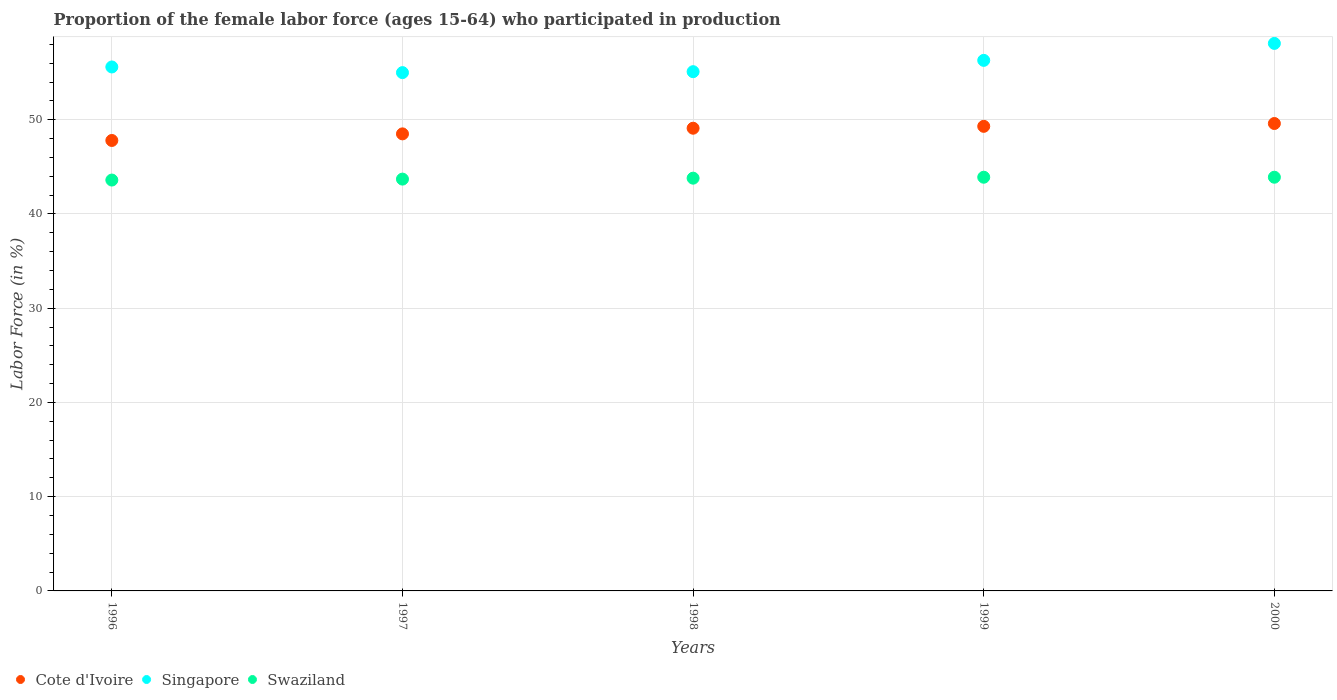What is the proportion of the female labor force who participated in production in Singapore in 2000?
Provide a succinct answer. 58.1. Across all years, what is the maximum proportion of the female labor force who participated in production in Swaziland?
Keep it short and to the point. 43.9. Across all years, what is the minimum proportion of the female labor force who participated in production in Swaziland?
Provide a short and direct response. 43.6. What is the total proportion of the female labor force who participated in production in Cote d'Ivoire in the graph?
Your answer should be very brief. 244.3. What is the difference between the proportion of the female labor force who participated in production in Cote d'Ivoire in 1996 and that in 1998?
Your answer should be compact. -1.3. What is the difference between the proportion of the female labor force who participated in production in Singapore in 1998 and the proportion of the female labor force who participated in production in Swaziland in 1999?
Make the answer very short. 11.2. What is the average proportion of the female labor force who participated in production in Cote d'Ivoire per year?
Give a very brief answer. 48.86. In the year 2000, what is the difference between the proportion of the female labor force who participated in production in Cote d'Ivoire and proportion of the female labor force who participated in production in Swaziland?
Provide a succinct answer. 5.7. What is the ratio of the proportion of the female labor force who participated in production in Swaziland in 1998 to that in 2000?
Give a very brief answer. 1. What is the difference between the highest and the second highest proportion of the female labor force who participated in production in Singapore?
Give a very brief answer. 1.8. What is the difference between the highest and the lowest proportion of the female labor force who participated in production in Swaziland?
Ensure brevity in your answer.  0.3. Does the proportion of the female labor force who participated in production in Singapore monotonically increase over the years?
Your response must be concise. No. Is the proportion of the female labor force who participated in production in Singapore strictly less than the proportion of the female labor force who participated in production in Cote d'Ivoire over the years?
Give a very brief answer. No. How many dotlines are there?
Offer a very short reply. 3. How many years are there in the graph?
Your answer should be compact. 5. What is the difference between two consecutive major ticks on the Y-axis?
Provide a short and direct response. 10. Where does the legend appear in the graph?
Your answer should be very brief. Bottom left. What is the title of the graph?
Keep it short and to the point. Proportion of the female labor force (ages 15-64) who participated in production. What is the label or title of the Y-axis?
Offer a terse response. Labor Force (in %). What is the Labor Force (in %) of Cote d'Ivoire in 1996?
Offer a terse response. 47.8. What is the Labor Force (in %) of Singapore in 1996?
Offer a terse response. 55.6. What is the Labor Force (in %) of Swaziland in 1996?
Make the answer very short. 43.6. What is the Labor Force (in %) in Cote d'Ivoire in 1997?
Your answer should be very brief. 48.5. What is the Labor Force (in %) of Swaziland in 1997?
Give a very brief answer. 43.7. What is the Labor Force (in %) of Cote d'Ivoire in 1998?
Your answer should be compact. 49.1. What is the Labor Force (in %) in Singapore in 1998?
Offer a very short reply. 55.1. What is the Labor Force (in %) in Swaziland in 1998?
Provide a short and direct response. 43.8. What is the Labor Force (in %) in Cote d'Ivoire in 1999?
Make the answer very short. 49.3. What is the Labor Force (in %) in Singapore in 1999?
Offer a very short reply. 56.3. What is the Labor Force (in %) of Swaziland in 1999?
Provide a succinct answer. 43.9. What is the Labor Force (in %) in Cote d'Ivoire in 2000?
Keep it short and to the point. 49.6. What is the Labor Force (in %) of Singapore in 2000?
Offer a very short reply. 58.1. What is the Labor Force (in %) in Swaziland in 2000?
Give a very brief answer. 43.9. Across all years, what is the maximum Labor Force (in %) in Cote d'Ivoire?
Offer a very short reply. 49.6. Across all years, what is the maximum Labor Force (in %) of Singapore?
Your answer should be very brief. 58.1. Across all years, what is the maximum Labor Force (in %) of Swaziland?
Provide a succinct answer. 43.9. Across all years, what is the minimum Labor Force (in %) of Cote d'Ivoire?
Ensure brevity in your answer.  47.8. Across all years, what is the minimum Labor Force (in %) of Singapore?
Provide a short and direct response. 55. Across all years, what is the minimum Labor Force (in %) in Swaziland?
Give a very brief answer. 43.6. What is the total Labor Force (in %) of Cote d'Ivoire in the graph?
Provide a succinct answer. 244.3. What is the total Labor Force (in %) in Singapore in the graph?
Give a very brief answer. 280.1. What is the total Labor Force (in %) in Swaziland in the graph?
Offer a terse response. 218.9. What is the difference between the Labor Force (in %) of Singapore in 1996 and that in 1998?
Offer a terse response. 0.5. What is the difference between the Labor Force (in %) in Cote d'Ivoire in 1996 and that in 1999?
Keep it short and to the point. -1.5. What is the difference between the Labor Force (in %) in Swaziland in 1996 and that in 1999?
Provide a short and direct response. -0.3. What is the difference between the Labor Force (in %) of Singapore in 1996 and that in 2000?
Ensure brevity in your answer.  -2.5. What is the difference between the Labor Force (in %) in Singapore in 1997 and that in 1998?
Offer a very short reply. -0.1. What is the difference between the Labor Force (in %) of Swaziland in 1997 and that in 1998?
Provide a succinct answer. -0.1. What is the difference between the Labor Force (in %) in Singapore in 1997 and that in 1999?
Your response must be concise. -1.3. What is the difference between the Labor Force (in %) of Swaziland in 1997 and that in 1999?
Provide a short and direct response. -0.2. What is the difference between the Labor Force (in %) of Swaziland in 1997 and that in 2000?
Your answer should be very brief. -0.2. What is the difference between the Labor Force (in %) in Cote d'Ivoire in 1998 and that in 1999?
Provide a succinct answer. -0.2. What is the difference between the Labor Force (in %) in Cote d'Ivoire in 1998 and that in 2000?
Provide a short and direct response. -0.5. What is the difference between the Labor Force (in %) in Singapore in 1998 and that in 2000?
Offer a very short reply. -3. What is the difference between the Labor Force (in %) in Swaziland in 1998 and that in 2000?
Provide a succinct answer. -0.1. What is the difference between the Labor Force (in %) in Singapore in 1999 and that in 2000?
Provide a short and direct response. -1.8. What is the difference between the Labor Force (in %) in Cote d'Ivoire in 1996 and the Labor Force (in %) in Swaziland in 1997?
Offer a terse response. 4.1. What is the difference between the Labor Force (in %) in Singapore in 1996 and the Labor Force (in %) in Swaziland in 1997?
Keep it short and to the point. 11.9. What is the difference between the Labor Force (in %) of Cote d'Ivoire in 1996 and the Labor Force (in %) of Singapore in 1999?
Keep it short and to the point. -8.5. What is the difference between the Labor Force (in %) in Singapore in 1996 and the Labor Force (in %) in Swaziland in 1999?
Your answer should be very brief. 11.7. What is the difference between the Labor Force (in %) in Cote d'Ivoire in 1996 and the Labor Force (in %) in Singapore in 2000?
Provide a short and direct response. -10.3. What is the difference between the Labor Force (in %) of Singapore in 1996 and the Labor Force (in %) of Swaziland in 2000?
Offer a terse response. 11.7. What is the difference between the Labor Force (in %) of Cote d'Ivoire in 1997 and the Labor Force (in %) of Swaziland in 1998?
Your answer should be very brief. 4.7. What is the difference between the Labor Force (in %) in Cote d'Ivoire in 1997 and the Labor Force (in %) in Singapore in 1999?
Offer a very short reply. -7.8. What is the difference between the Labor Force (in %) in Singapore in 1997 and the Labor Force (in %) in Swaziland in 1999?
Your response must be concise. 11.1. What is the difference between the Labor Force (in %) of Cote d'Ivoire in 1997 and the Labor Force (in %) of Singapore in 2000?
Give a very brief answer. -9.6. What is the difference between the Labor Force (in %) in Cote d'Ivoire in 1998 and the Labor Force (in %) in Swaziland in 1999?
Give a very brief answer. 5.2. What is the difference between the Labor Force (in %) in Singapore in 1998 and the Labor Force (in %) in Swaziland in 1999?
Give a very brief answer. 11.2. What is the difference between the Labor Force (in %) of Cote d'Ivoire in 1998 and the Labor Force (in %) of Singapore in 2000?
Give a very brief answer. -9. What is the difference between the Labor Force (in %) in Cote d'Ivoire in 1998 and the Labor Force (in %) in Swaziland in 2000?
Offer a terse response. 5.2. What is the difference between the Labor Force (in %) of Singapore in 1998 and the Labor Force (in %) of Swaziland in 2000?
Your response must be concise. 11.2. What is the difference between the Labor Force (in %) of Cote d'Ivoire in 1999 and the Labor Force (in %) of Singapore in 2000?
Keep it short and to the point. -8.8. What is the average Labor Force (in %) of Cote d'Ivoire per year?
Your response must be concise. 48.86. What is the average Labor Force (in %) in Singapore per year?
Offer a terse response. 56.02. What is the average Labor Force (in %) in Swaziland per year?
Keep it short and to the point. 43.78. In the year 1996, what is the difference between the Labor Force (in %) in Singapore and Labor Force (in %) in Swaziland?
Your answer should be very brief. 12. In the year 1997, what is the difference between the Labor Force (in %) of Cote d'Ivoire and Labor Force (in %) of Singapore?
Provide a short and direct response. -6.5. In the year 1997, what is the difference between the Labor Force (in %) in Cote d'Ivoire and Labor Force (in %) in Swaziland?
Your response must be concise. 4.8. In the year 1998, what is the difference between the Labor Force (in %) of Cote d'Ivoire and Labor Force (in %) of Singapore?
Your answer should be very brief. -6. In the year 1998, what is the difference between the Labor Force (in %) of Cote d'Ivoire and Labor Force (in %) of Swaziland?
Your answer should be compact. 5.3. In the year 1998, what is the difference between the Labor Force (in %) of Singapore and Labor Force (in %) of Swaziland?
Make the answer very short. 11.3. In the year 1999, what is the difference between the Labor Force (in %) in Singapore and Labor Force (in %) in Swaziland?
Your answer should be compact. 12.4. In the year 2000, what is the difference between the Labor Force (in %) of Cote d'Ivoire and Labor Force (in %) of Singapore?
Make the answer very short. -8.5. In the year 2000, what is the difference between the Labor Force (in %) of Cote d'Ivoire and Labor Force (in %) of Swaziland?
Your answer should be very brief. 5.7. What is the ratio of the Labor Force (in %) of Cote d'Ivoire in 1996 to that in 1997?
Make the answer very short. 0.99. What is the ratio of the Labor Force (in %) in Singapore in 1996 to that in 1997?
Provide a succinct answer. 1.01. What is the ratio of the Labor Force (in %) of Swaziland in 1996 to that in 1997?
Your answer should be compact. 1. What is the ratio of the Labor Force (in %) in Cote d'Ivoire in 1996 to that in 1998?
Your answer should be compact. 0.97. What is the ratio of the Labor Force (in %) in Singapore in 1996 to that in 1998?
Your answer should be very brief. 1.01. What is the ratio of the Labor Force (in %) of Swaziland in 1996 to that in 1998?
Ensure brevity in your answer.  1. What is the ratio of the Labor Force (in %) in Cote d'Ivoire in 1996 to that in 1999?
Your response must be concise. 0.97. What is the ratio of the Labor Force (in %) in Singapore in 1996 to that in 1999?
Give a very brief answer. 0.99. What is the ratio of the Labor Force (in %) of Swaziland in 1996 to that in 1999?
Provide a succinct answer. 0.99. What is the ratio of the Labor Force (in %) in Cote d'Ivoire in 1996 to that in 2000?
Give a very brief answer. 0.96. What is the ratio of the Labor Force (in %) of Singapore in 1996 to that in 2000?
Your answer should be very brief. 0.96. What is the ratio of the Labor Force (in %) of Cote d'Ivoire in 1997 to that in 1998?
Keep it short and to the point. 0.99. What is the ratio of the Labor Force (in %) in Singapore in 1997 to that in 1998?
Give a very brief answer. 1. What is the ratio of the Labor Force (in %) in Swaziland in 1997 to that in 1998?
Your answer should be compact. 1. What is the ratio of the Labor Force (in %) in Cote d'Ivoire in 1997 to that in 1999?
Your response must be concise. 0.98. What is the ratio of the Labor Force (in %) of Singapore in 1997 to that in 1999?
Provide a succinct answer. 0.98. What is the ratio of the Labor Force (in %) in Swaziland in 1997 to that in 1999?
Offer a very short reply. 1. What is the ratio of the Labor Force (in %) in Cote d'Ivoire in 1997 to that in 2000?
Give a very brief answer. 0.98. What is the ratio of the Labor Force (in %) in Singapore in 1997 to that in 2000?
Ensure brevity in your answer.  0.95. What is the ratio of the Labor Force (in %) of Cote d'Ivoire in 1998 to that in 1999?
Make the answer very short. 1. What is the ratio of the Labor Force (in %) in Singapore in 1998 to that in 1999?
Your response must be concise. 0.98. What is the ratio of the Labor Force (in %) of Singapore in 1998 to that in 2000?
Give a very brief answer. 0.95. What is the difference between the highest and the second highest Labor Force (in %) of Cote d'Ivoire?
Keep it short and to the point. 0.3. What is the difference between the highest and the second highest Labor Force (in %) of Singapore?
Keep it short and to the point. 1.8. What is the difference between the highest and the second highest Labor Force (in %) of Swaziland?
Your answer should be very brief. 0. 